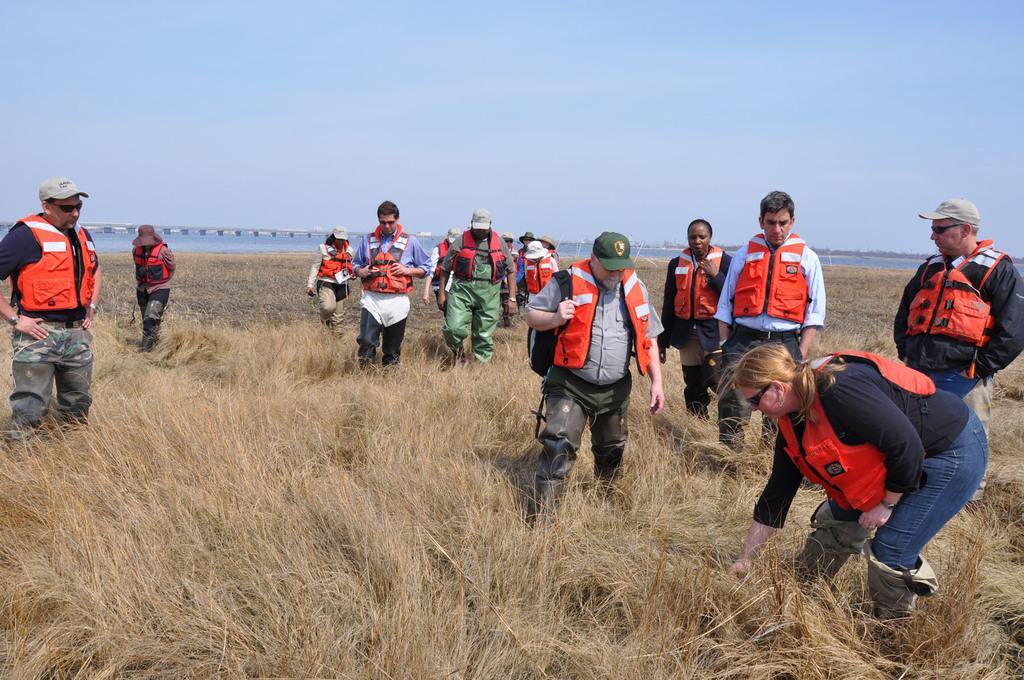How many people are in the image? There is a group of people in the image, but the exact number is not specified. What are the people doing in the image? The people are on the ground, but their specific activity is not mentioned. What type of vegetation is present in the image? There is dried grass in the image. What can be seen in the background of the image? The sky is visible in the background of the image. How many minutes does it take for the fish to swim in the stomach of the person in the image? There is no fish or person mentioned in the image, so this question cannot be answered. 